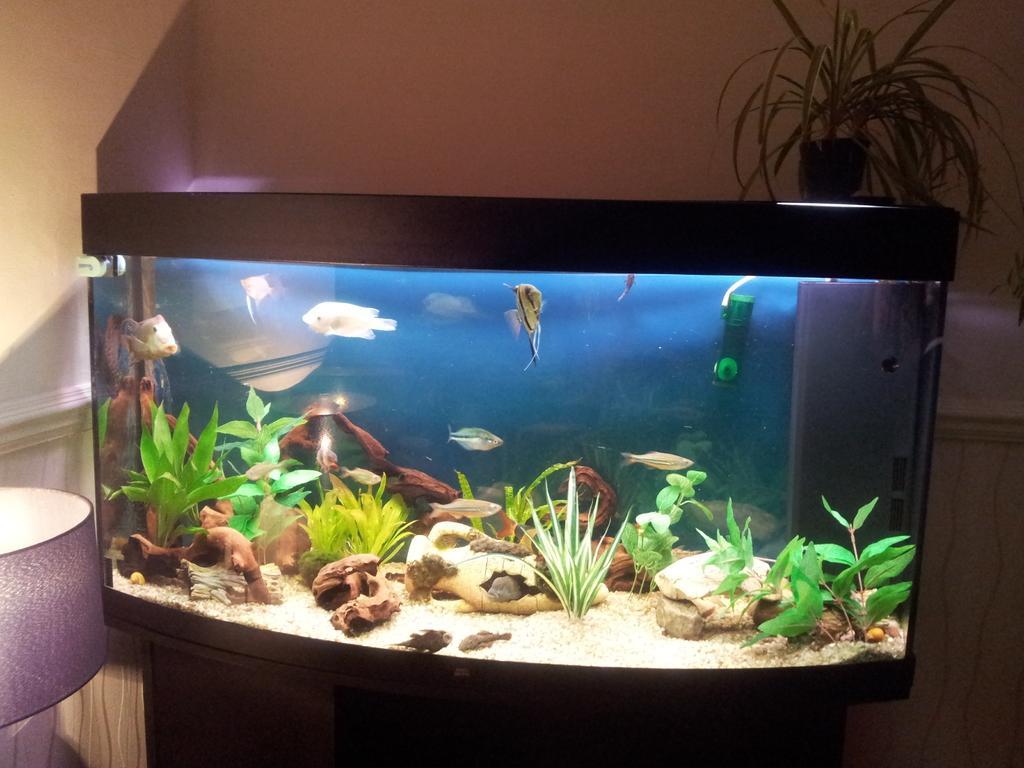Describe this image in one or two sentences. In this picture we can observe an aquarium. There are some plants and stones inside the aquarium. We can observe some fish swimming in the water. There is a plant and a plant pot placed on the aquarium. On the left side we can observe a lamp. In the background there is a wall. 